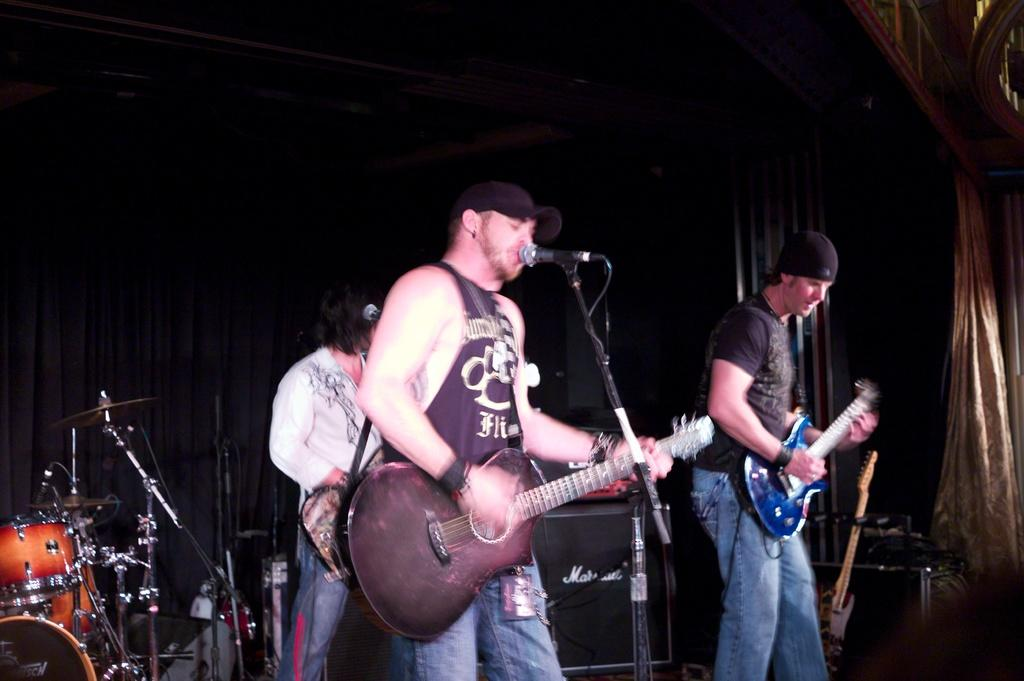What type of performance is taking place in the image? There is a rock band performing in the image. How many musicians are holding guitars? Three men are holding guitars. Can you describe the appearance of the singer? One man is wearing a black cap and singing. What instrument is typically used for rhythm in a rock band? There is a drum set behind the musicians, which is commonly used for rhythm. Is there a chain hanging from the ceiling in the image? There is no chain hanging from the ceiling in the image. How many men are walking in the rainstorm in the image? There is no rainstorm or men walking in the image; it features a rock band performing. 